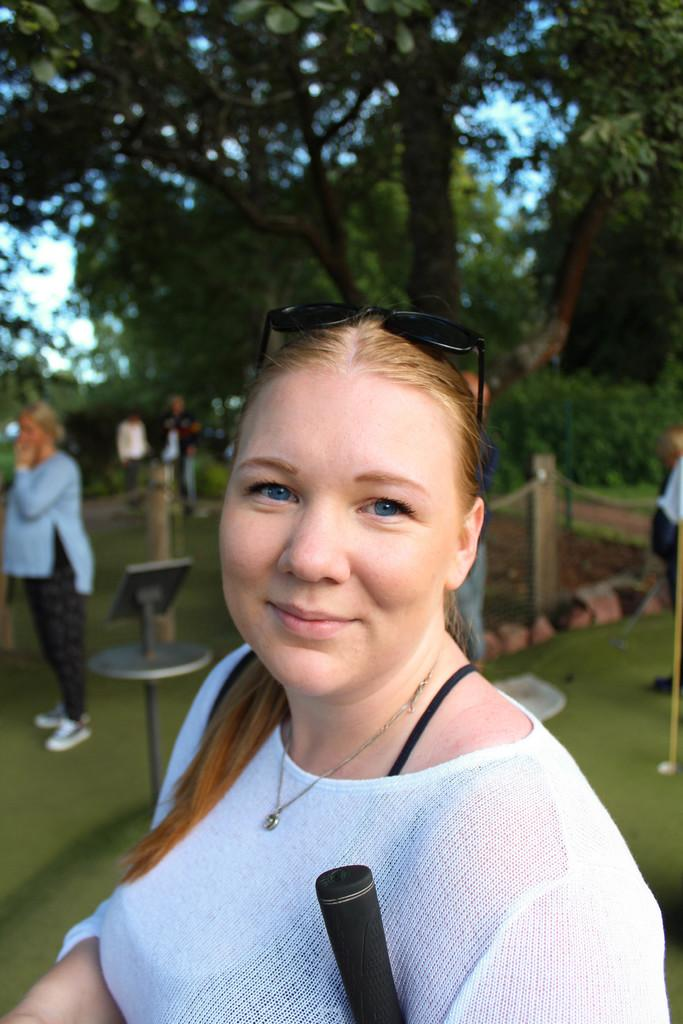Who is the main subject in the image? There is a woman in the image. What expression does the woman have on her face? The woman has a smile on her face. Can you describe the second woman in the image? There is another woman behind the first woman. What can be seen in the background of the image? There are trees in the background of the image. What type of rail can be seen in the image? There is no rail present in the image. How many copies of the woman are there in the image? There is only one woman in the image, so there are no copies. 